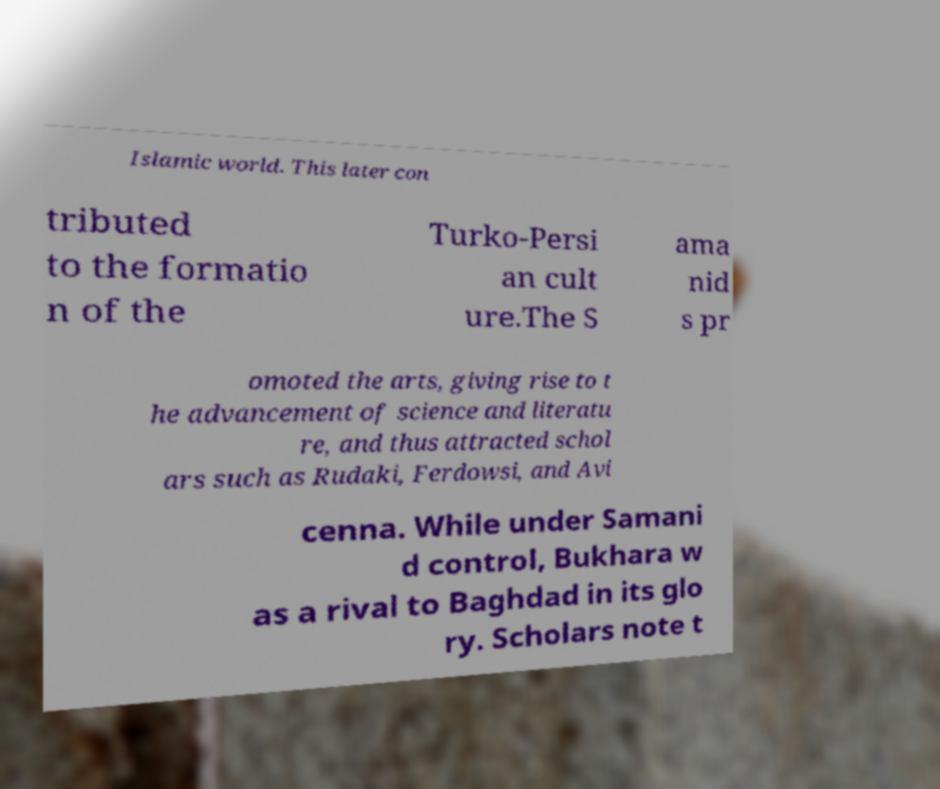What messages or text are displayed in this image? I need them in a readable, typed format. Islamic world. This later con tributed to the formatio n of the Turko-Persi an cult ure.The S ama nid s pr omoted the arts, giving rise to t he advancement of science and literatu re, and thus attracted schol ars such as Rudaki, Ferdowsi, and Avi cenna. While under Samani d control, Bukhara w as a rival to Baghdad in its glo ry. Scholars note t 